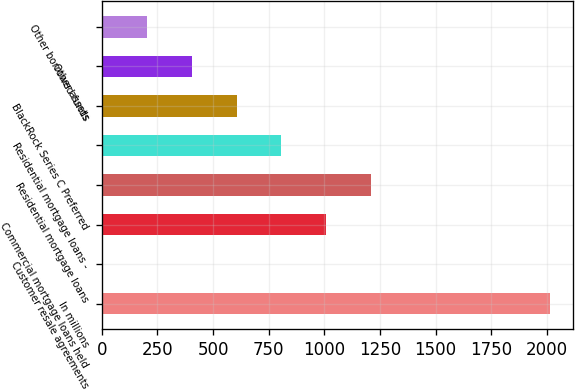Convert chart to OTSL. <chart><loc_0><loc_0><loc_500><loc_500><bar_chart><fcel>In millions<fcel>Customer resale agreements<fcel>Commercial mortgage loans held<fcel>Residential mortgage loans<fcel>Residential mortgage loans -<fcel>BlackRock Series C Preferred<fcel>Other assets<fcel>Other borrowed funds<nl><fcel>2015<fcel>2<fcel>1008.5<fcel>1209.8<fcel>807.2<fcel>605.9<fcel>404.6<fcel>203.3<nl></chart> 